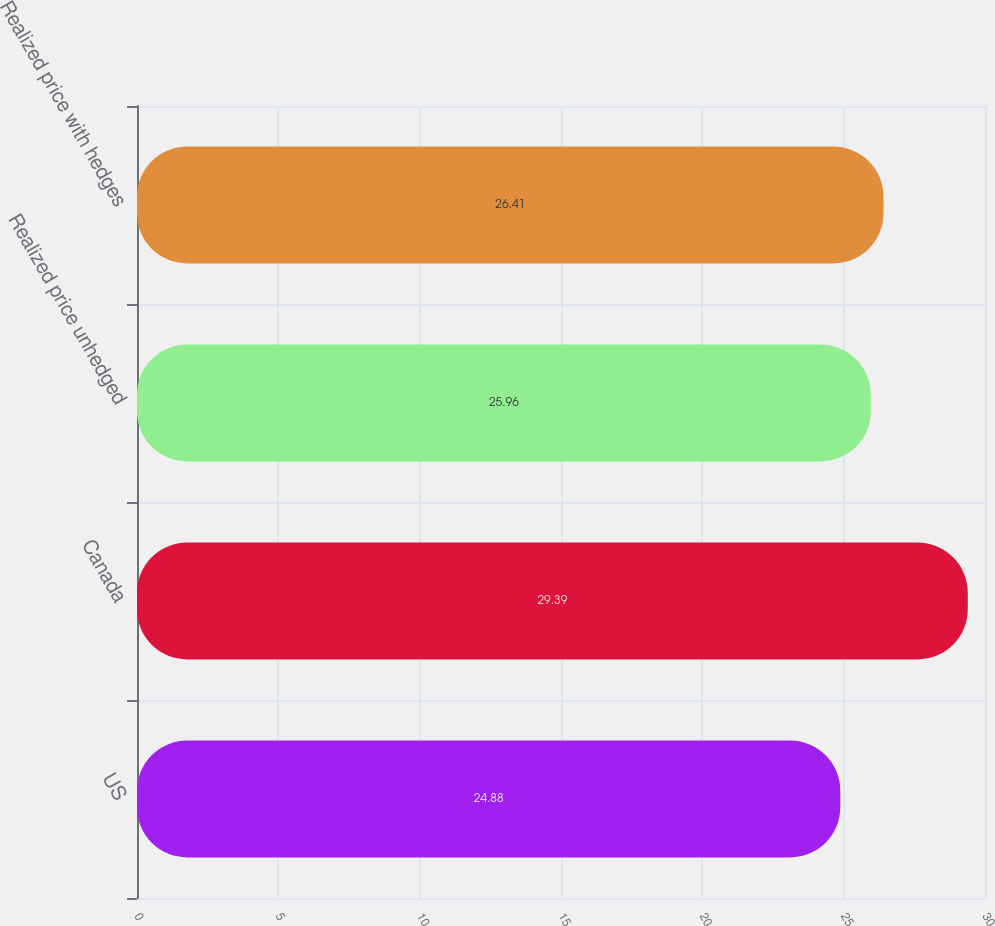Convert chart. <chart><loc_0><loc_0><loc_500><loc_500><bar_chart><fcel>US<fcel>Canada<fcel>Realized price unhedged<fcel>Realized price with hedges<nl><fcel>24.88<fcel>29.39<fcel>25.96<fcel>26.41<nl></chart> 